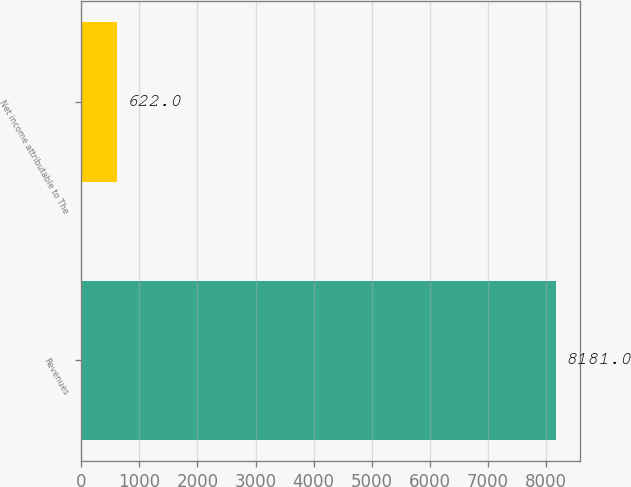<chart> <loc_0><loc_0><loc_500><loc_500><bar_chart><fcel>Revenues<fcel>Net income attributable to The<nl><fcel>8181<fcel>622<nl></chart> 